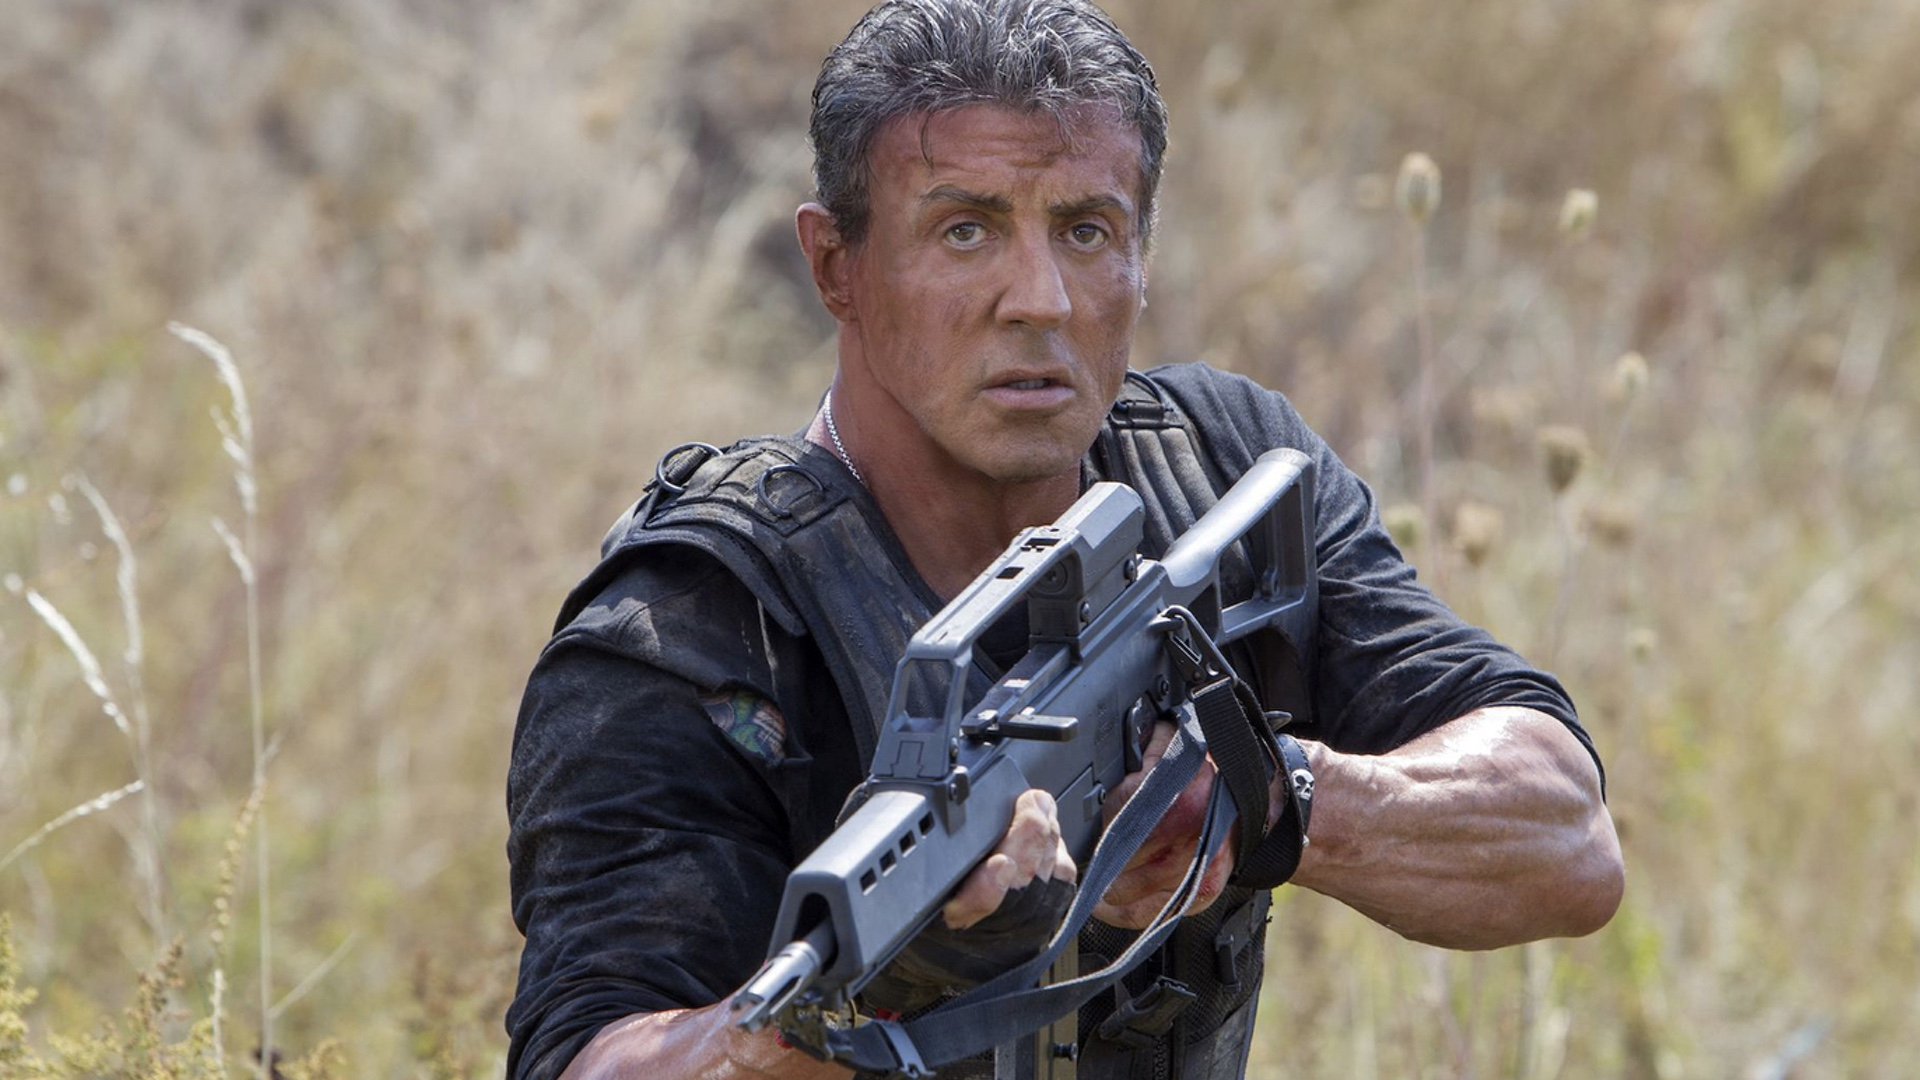What does the character's expression convey about his mental state? The character's intense, focused expression conveys a strong determination and readiness to face challenges. It suggests a significant level of emotional intensity, likely due to the high-stakes situation he is in. Can you describe the significance of his tactical gear? The tactical gear, comprising various pouches and a rugged vest, indicates practical necessity for survival and combat. It underscores his preparedness and the serious nature of his mission, providing utility as well as protection. 